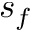Convert formula to latex. <formula><loc_0><loc_0><loc_500><loc_500>s _ { f }</formula> 